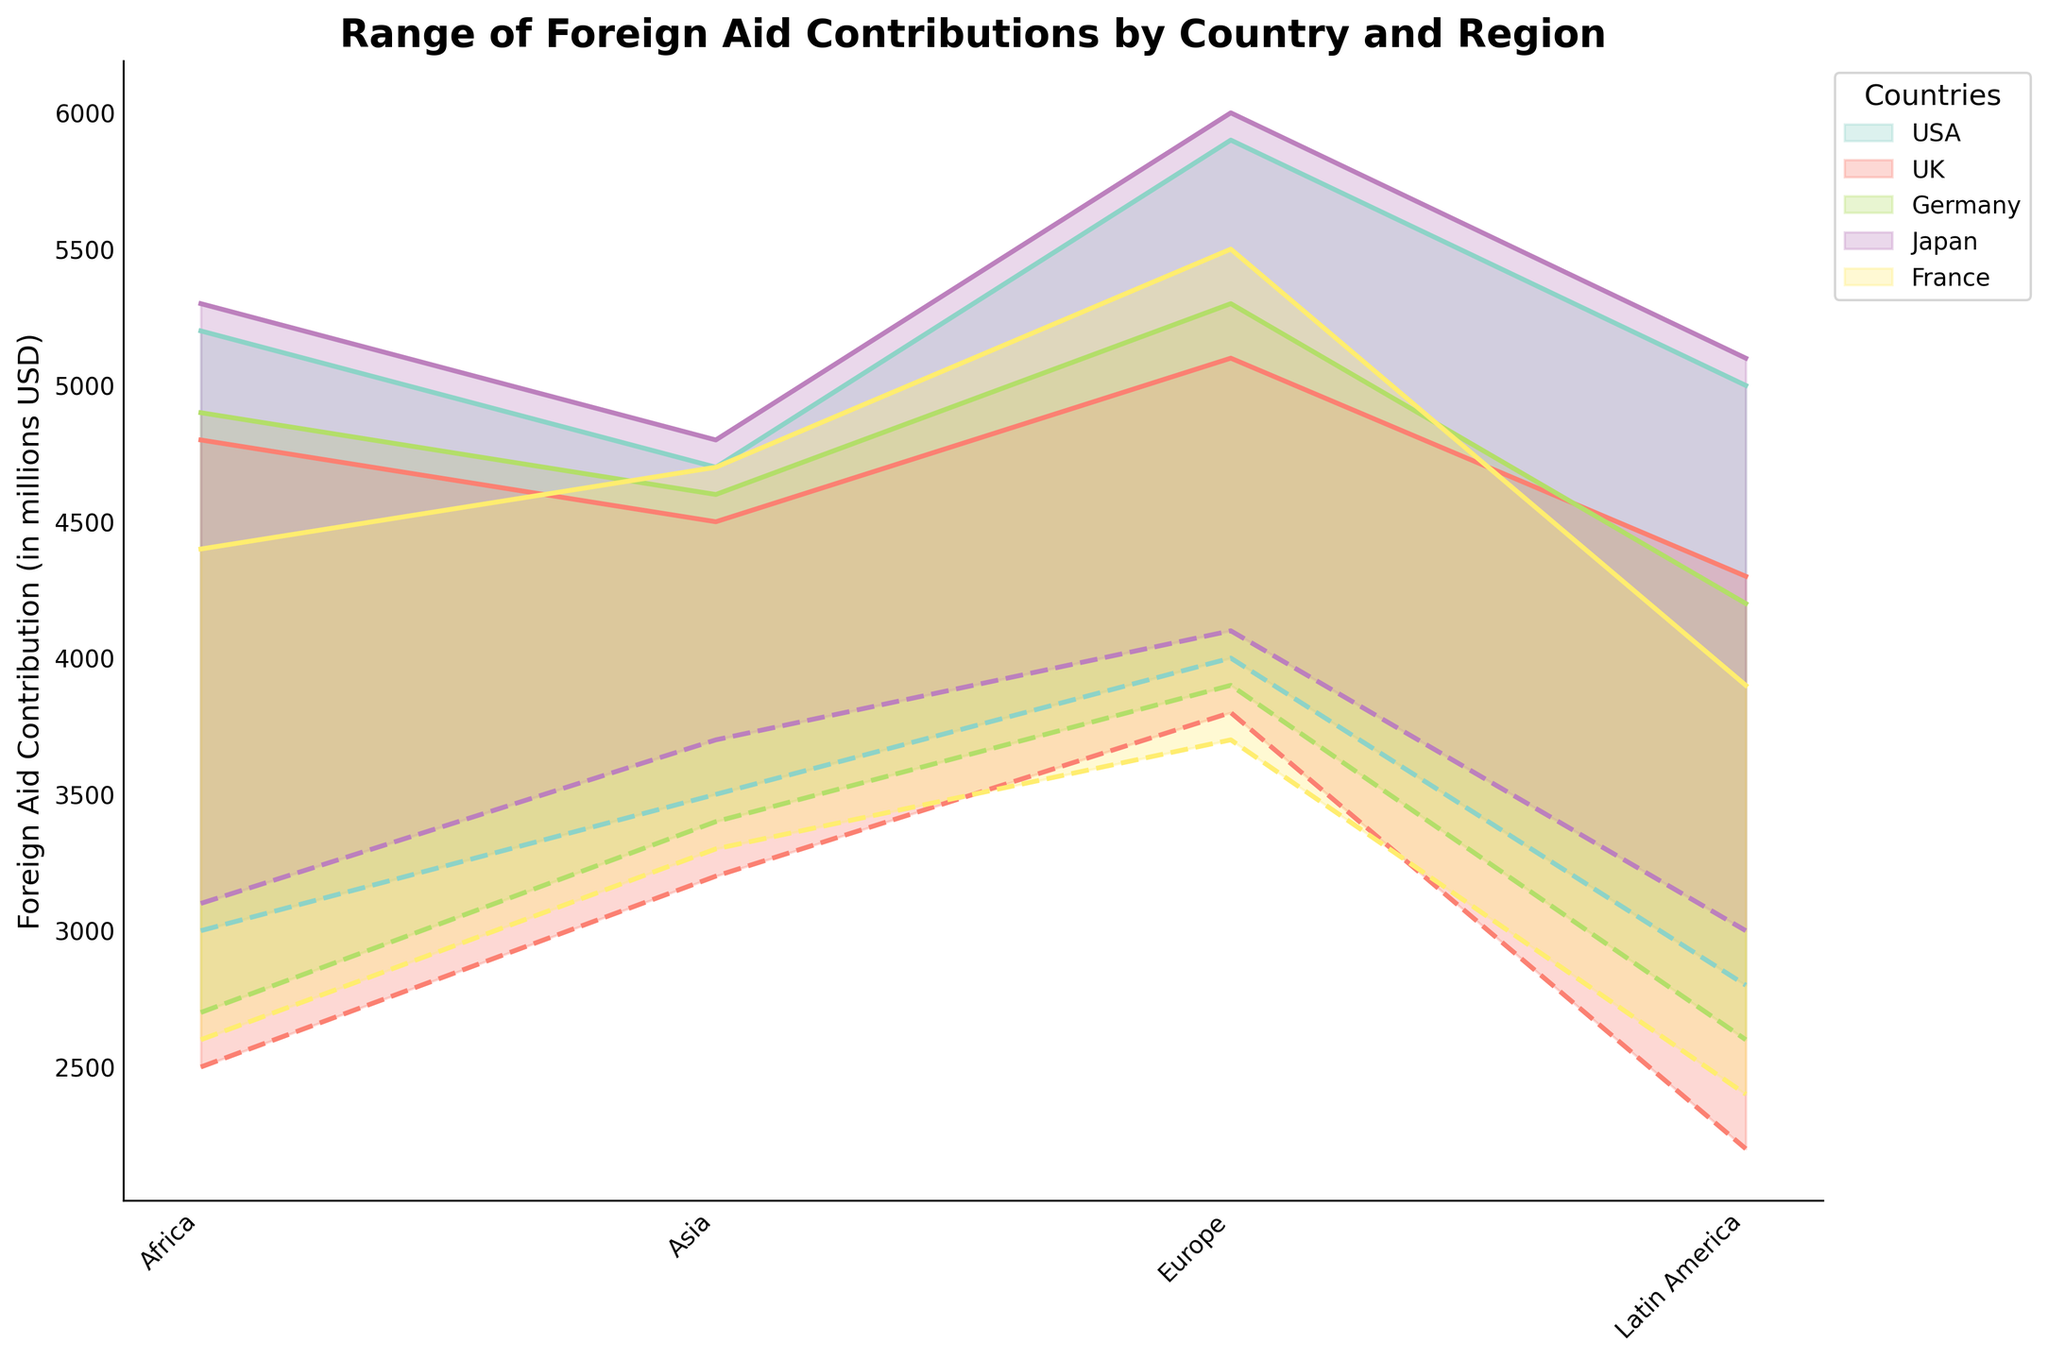What is the title of the figure? The title is located at the top of the figure. "Range of Foreign Aid Contributions by Country and Region" is written there, indicating that this is the chart's title.
Answer: Range of Foreign Aid Contributions by Country and Region Which country has the highest maximum aid contribution to Europe? By looking at the top lines of each range in the Europe region, we can compare the maximum values. Japan's line reaches the highest value.
Answer: Japan What is the difference between the USA's maximum and minimum aid contributions to Africa? The USA's max contribution to Africa is 5200 million USD, and the min is 3000 million USD. The difference is 5200 - 3000 = 2200 million USD.
Answer: 2200 Which region has the smallest range of aid contributions from France? By comparing the filled areas for France across different regions, the Latin America region has the smallest range from 2400 to 3900 million USD, resulting in a 1500 million USD range.
Answer: Latin America If you add up the maximum aid contributions from the UK to all regions, what is the total? UK max aid to Africa: 4800, Asia: 4500, Europe: 5100, Latin America: 4300. Summing these gives 4800 + 4500 + 5100 + 4300 = 18700 million USD.
Answer: 18700 Which country has the smallest minimum aid contribution to Latin America? By looking at the bottom lines of each range in the Latin America region, France has the lowest minimum aid contribution at 2400 million USD.
Answer: France By how much does Japan's maximum aid contribution to Europe exceed Germany's maximum aid contribution to Europe? Japan's max aid to Europe is 6000 million USD, and Germany's max aid to Europe is 5300 million USD. The difference is 6000 - 5300 = 700 million USD.
Answer: 700 Which region gets the most consistent (smallest range) aid contribution from Germany? Comparing the filled ranges for Germany, Latin America has the smallest range from 2600 to 4200 million USD, resulting in a range of 1600 million USD.
Answer: Latin America What is the average of the minimum aid contributions to Asia from all countries? Minimum aid to Asia: USA: 3500, UK: 3200, Germany: 3400, Japan: 3700, France: 3300. (3500 + 3200 + 3400 + 3700 + 3300) / 5 = 3420 million USD.
Answer: 3420 Comparing the maximum aid contributions, which country gives more aid to Africa, Japan or France? By comparing the top lines in the Africa region, Japan’s maximum aid contribution is 5300 million USD while France’s is 4400 million USD. Japan gives more aid.
Answer: Japan 